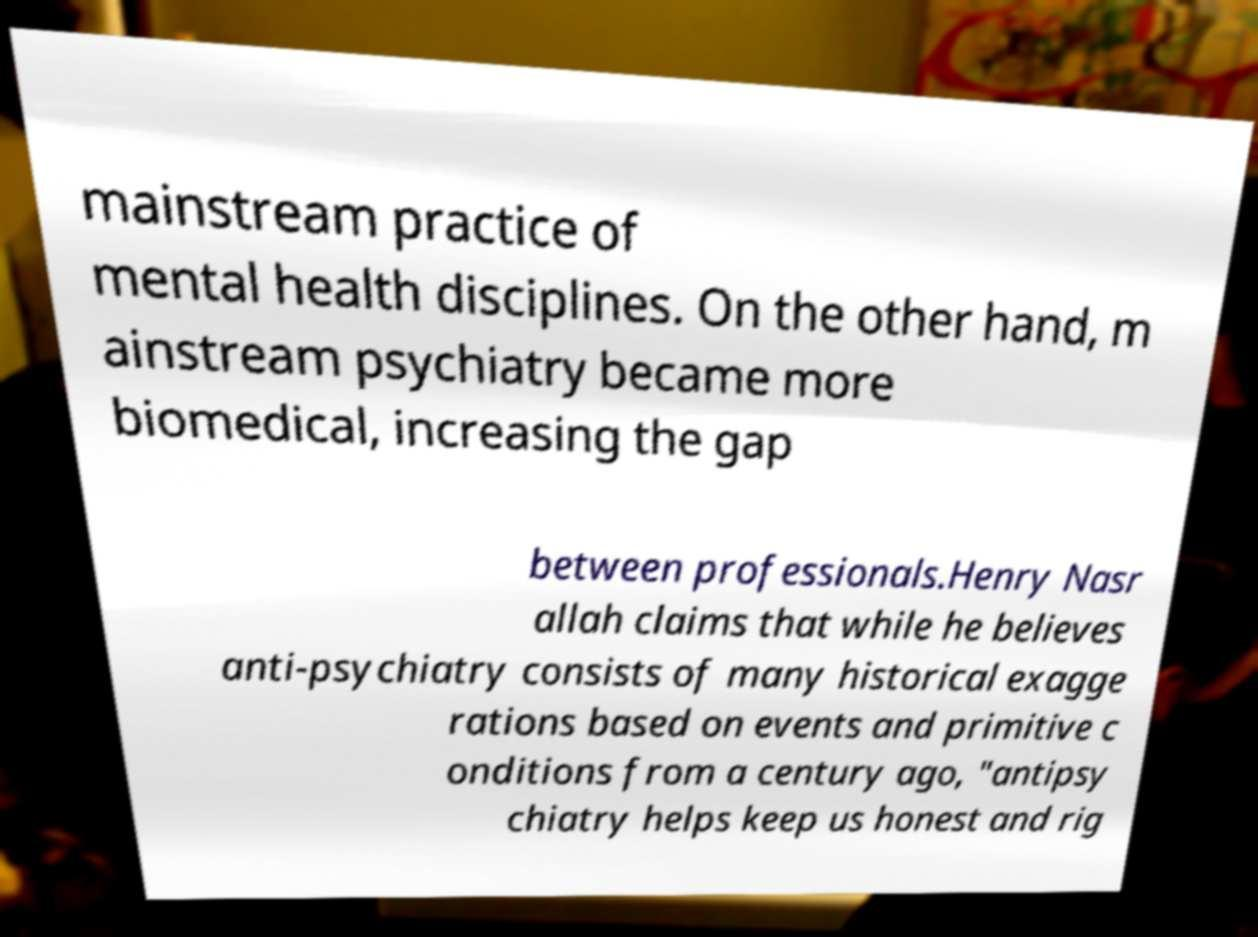What messages or text are displayed in this image? I need them in a readable, typed format. mainstream practice of mental health disciplines. On the other hand, m ainstream psychiatry became more biomedical, increasing the gap between professionals.Henry Nasr allah claims that while he believes anti-psychiatry consists of many historical exagge rations based on events and primitive c onditions from a century ago, "antipsy chiatry helps keep us honest and rig 